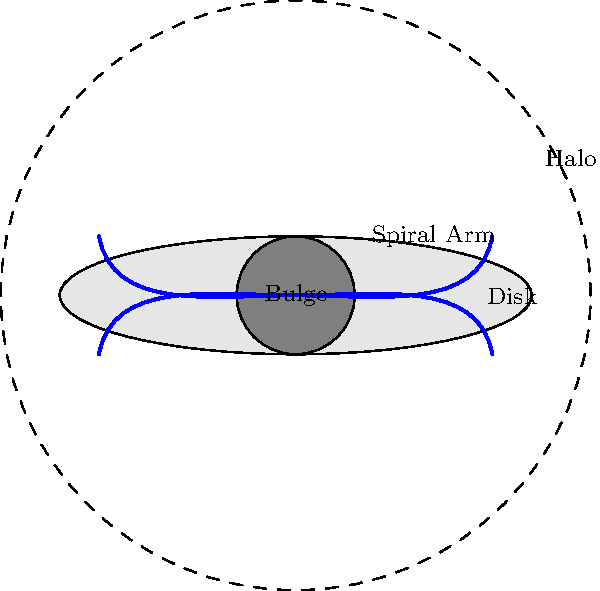As a master software developer, you're tasked with creating a simulation of galaxy formation. Which component of a spiral galaxy, as shown in the diagram, would you model first to accurately represent the galaxy's overall structure and evolution? To determine which component to model first in a galaxy formation simulation, let's consider the formation process and importance of each component:

1. Bulge: 
   - Central, spheroidal component
   - Contains older stars and a supermassive black hole
   - Forms early in galaxy evolution

2. Disk:
   - Flattened structure containing spiral arms
   - Contains younger stars, gas, and dust
   - Forms after the initial collapse of matter

3. Halo:
   - Spherical region surrounding the galaxy
   - Contains dark matter, old stars, and globular clusters
   - Extends beyond the visible disk

4. Spiral Arms:
   - Part of the disk structure
   - Regions of active star formation
   - Develop later in galaxy evolution

From a software development perspective, the most logical component to model first would be the halo. Here's why:

1. Initial Conditions: The halo, particularly its dark matter component, provides the initial gravitational potential well that influences the overall galaxy formation.

2. Large-scale Structure: The halo defines the galaxy's overall size and mass distribution, which is crucial for subsequent formation processes.

3. Gravitational Framework: Modeling the halo first allows you to establish the gravitational framework within which other components will form and evolve.

4. Computational Efficiency: Starting with the halo allows for a more efficient simulation, as it provides a stable background for modeling the more complex dynamics of the disk and bulge.

5. Hierarchical Formation: In the current understanding of galaxy formation, structures form hierarchically, with the halo forming first in the cosmic web.

By modeling the halo first, you create a solid foundation for the simulation, upon which you can then build the bulge, disk, and spiral arm components in a physically consistent manner.
Answer: Halo 